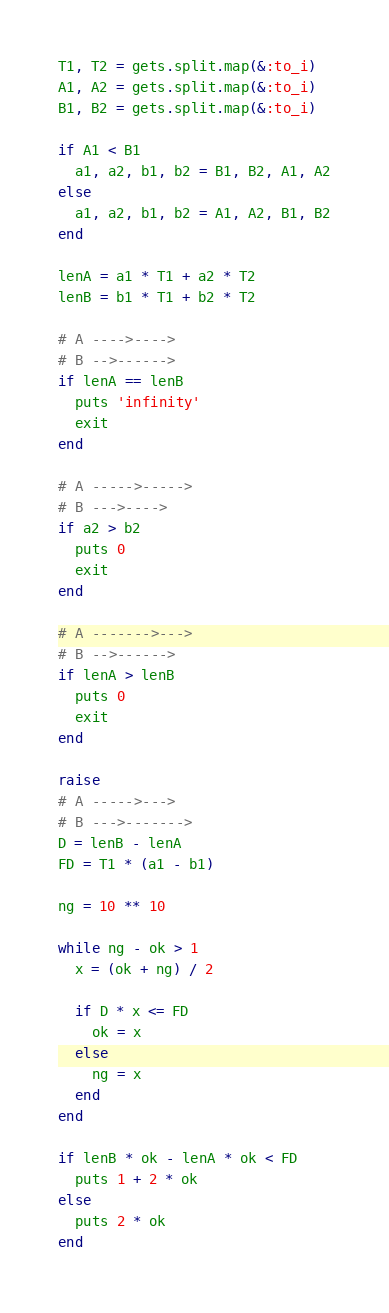<code> <loc_0><loc_0><loc_500><loc_500><_Ruby_>T1, T2 = gets.split.map(&:to_i)
A1, A2 = gets.split.map(&:to_i)
B1, B2 = gets.split.map(&:to_i)

if A1 < B1
  a1, a2, b1, b2 = B1, B2, A1, A2
else
  a1, a2, b1, b2 = A1, A2, B1, B2
end

lenA = a1 * T1 + a2 * T2
lenB = b1 * T1 + b2 * T2

# A ---->---->
# B -->------>
if lenA == lenB
  puts 'infinity'
  exit
end

# A ----->----->
# B --->---->
if a2 > b2
  puts 0
  exit
end

# A ------->--->
# B -->------>
if lenA > lenB
  puts 0
  exit
end

raise
# A ----->--->
# B --->------->
D = lenB - lenA
FD = T1 * (a1 - b1)

ng = 10 ** 10

while ng - ok > 1
  x = (ok + ng) / 2

  if D * x <= FD
    ok = x
  else
    ng = x
  end
end

if lenB * ok - lenA * ok < FD
  puts 1 + 2 * ok
else
  puts 2 * ok
end
</code> 